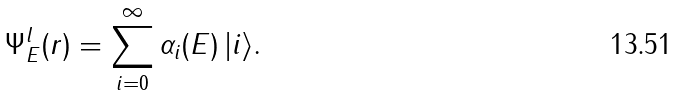Convert formula to latex. <formula><loc_0><loc_0><loc_500><loc_500>\Psi ^ { l } _ { E } ( r ) = \sum _ { i = 0 } ^ { \infty } \alpha _ { i } ( E ) \, | i \rangle .</formula> 